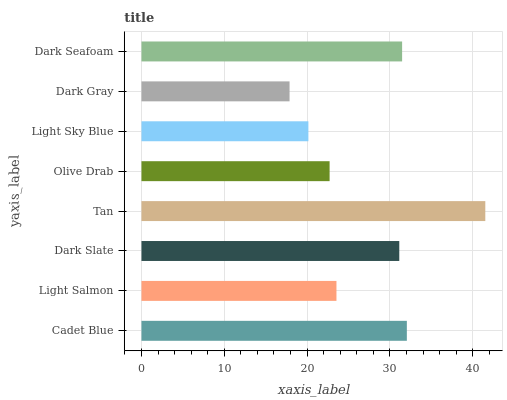Is Dark Gray the minimum?
Answer yes or no. Yes. Is Tan the maximum?
Answer yes or no. Yes. Is Light Salmon the minimum?
Answer yes or no. No. Is Light Salmon the maximum?
Answer yes or no. No. Is Cadet Blue greater than Light Salmon?
Answer yes or no. Yes. Is Light Salmon less than Cadet Blue?
Answer yes or no. Yes. Is Light Salmon greater than Cadet Blue?
Answer yes or no. No. Is Cadet Blue less than Light Salmon?
Answer yes or no. No. Is Dark Slate the high median?
Answer yes or no. Yes. Is Light Salmon the low median?
Answer yes or no. Yes. Is Tan the high median?
Answer yes or no. No. Is Tan the low median?
Answer yes or no. No. 